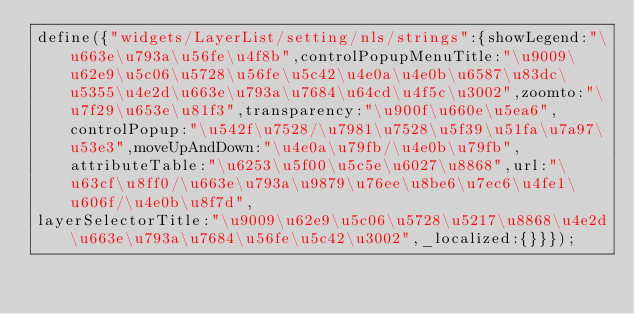Convert code to text. <code><loc_0><loc_0><loc_500><loc_500><_JavaScript_>define({"widgets/LayerList/setting/nls/strings":{showLegend:"\u663e\u793a\u56fe\u4f8b",controlPopupMenuTitle:"\u9009\u62e9\u5c06\u5728\u56fe\u5c42\u4e0a\u4e0b\u6587\u83dc\u5355\u4e2d\u663e\u793a\u7684\u64cd\u4f5c\u3002",zoomto:"\u7f29\u653e\u81f3",transparency:"\u900f\u660e\u5ea6",controlPopup:"\u542f\u7528/\u7981\u7528\u5f39\u51fa\u7a97\u53e3",moveUpAndDown:"\u4e0a\u79fb/\u4e0b\u79fb",attributeTable:"\u6253\u5f00\u5c5e\u6027\u8868",url:"\u63cf\u8ff0/\u663e\u793a\u9879\u76ee\u8be6\u7ec6\u4fe1\u606f/\u4e0b\u8f7d",
layerSelectorTitle:"\u9009\u62e9\u5c06\u5728\u5217\u8868\u4e2d\u663e\u793a\u7684\u56fe\u5c42\u3002",_localized:{}}});</code> 